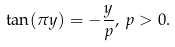<formula> <loc_0><loc_0><loc_500><loc_500>\tan ( \pi y ) = - \frac { y } { p } , \, p > 0 .</formula> 